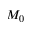Convert formula to latex. <formula><loc_0><loc_0><loc_500><loc_500>M _ { 0 }</formula> 